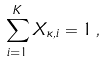<formula> <loc_0><loc_0><loc_500><loc_500>\sum _ { i = 1 } ^ { K } X _ { \kappa , i } = 1 \, ,</formula> 